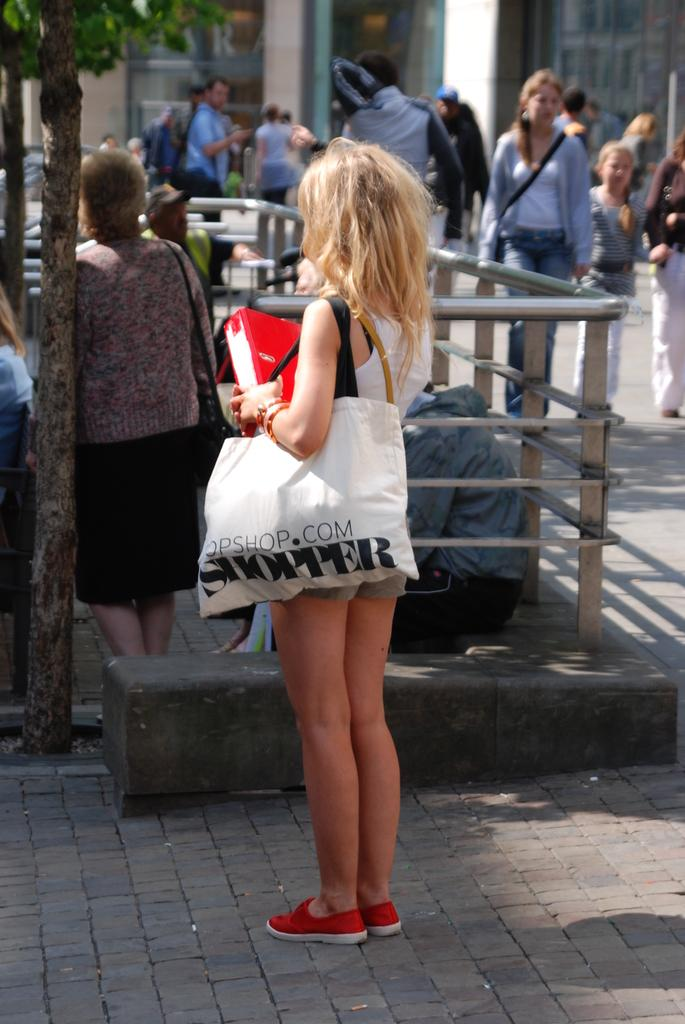<image>
Give a short and clear explanation of the subsequent image. A girl is holding a white bag with the word shopper on it. 